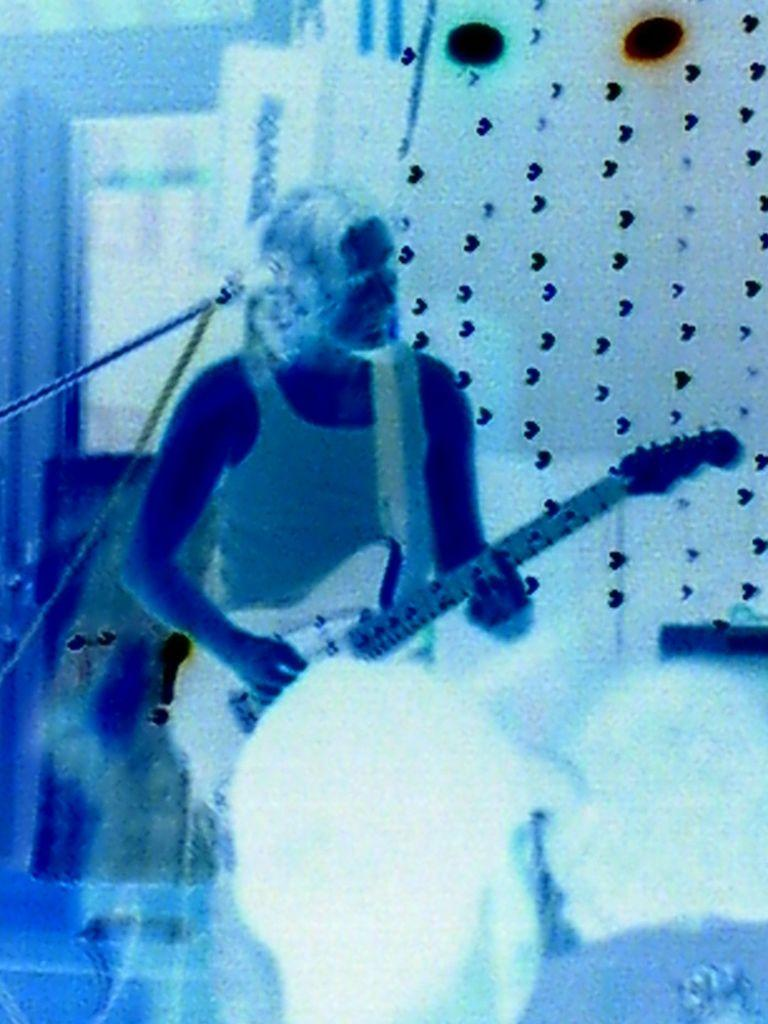Who or what can be seen in the image? There are people in the image. What object is present that is typically used for amplifying sound? There is a microphone in the image. What type of structure is visible in the background? There is a wall in the image. What part of the natural environment is visible in the image? The ground is visible in the image. Where is the nest located in the image? There is no nest present in the image. What type of receipt can be seen in the hands of the people in the image? There is no receipt visible in the image. 